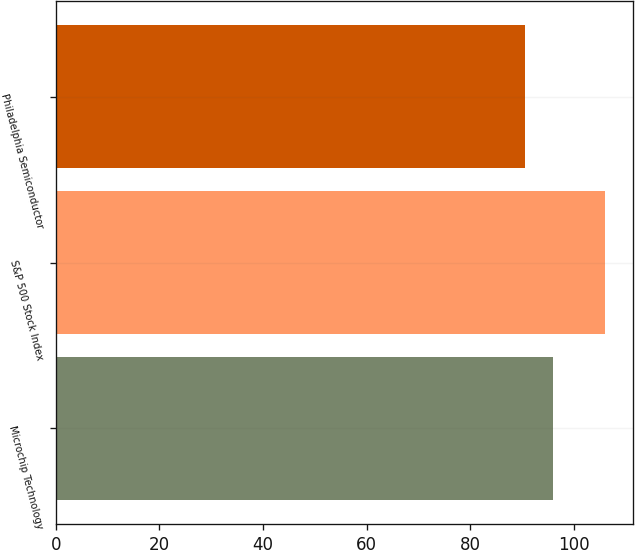Convert chart. <chart><loc_0><loc_0><loc_500><loc_500><bar_chart><fcel>Microchip Technology<fcel>S&P 500 Stock Index<fcel>Philadelphia Semiconductor<nl><fcel>96<fcel>106.15<fcel>90.68<nl></chart> 